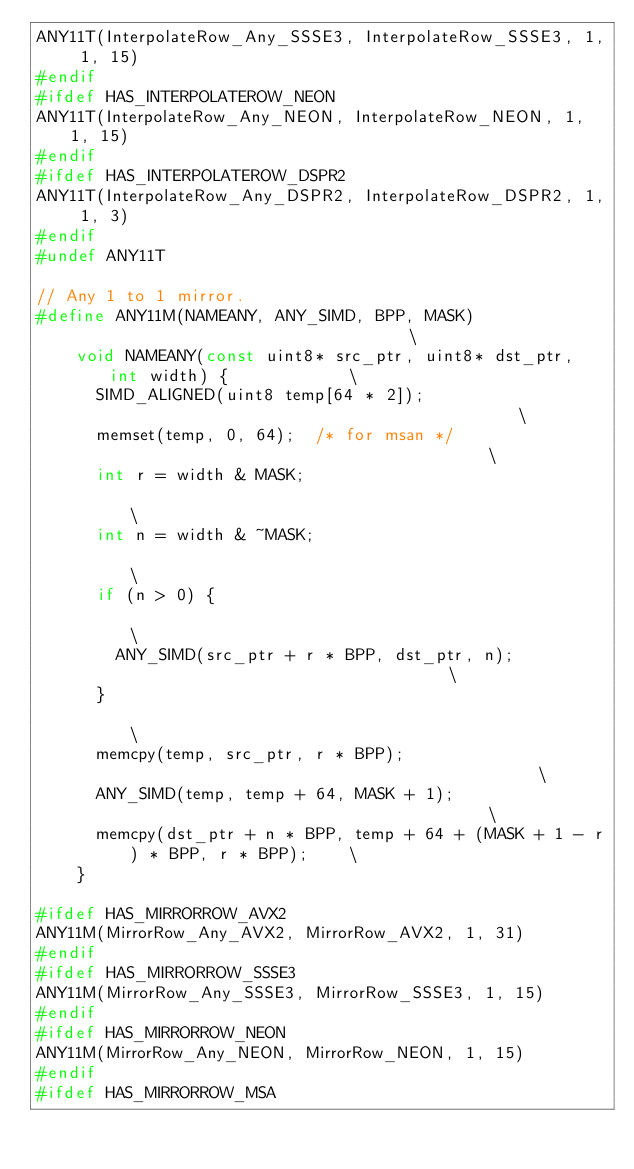Convert code to text. <code><loc_0><loc_0><loc_500><loc_500><_C++_>ANY11T(InterpolateRow_Any_SSSE3, InterpolateRow_SSSE3, 1, 1, 15)
#endif
#ifdef HAS_INTERPOLATEROW_NEON
ANY11T(InterpolateRow_Any_NEON, InterpolateRow_NEON, 1, 1, 15)
#endif
#ifdef HAS_INTERPOLATEROW_DSPR2
ANY11T(InterpolateRow_Any_DSPR2, InterpolateRow_DSPR2, 1, 1, 3)
#endif
#undef ANY11T

// Any 1 to 1 mirror.
#define ANY11M(NAMEANY, ANY_SIMD, BPP, MASK)                                   \
    void NAMEANY(const uint8* src_ptr, uint8* dst_ptr, int width) {            \
      SIMD_ALIGNED(uint8 temp[64 * 2]);                                        \
      memset(temp, 0, 64);  /* for msan */                                     \
      int r = width & MASK;                                                    \
      int n = width & ~MASK;                                                   \
      if (n > 0) {                                                             \
        ANY_SIMD(src_ptr + r * BPP, dst_ptr, n);                               \
      }                                                                        \
      memcpy(temp, src_ptr, r * BPP);                                          \
      ANY_SIMD(temp, temp + 64, MASK + 1);                                     \
      memcpy(dst_ptr + n * BPP, temp + 64 + (MASK + 1 - r) * BPP, r * BPP);    \
    }

#ifdef HAS_MIRRORROW_AVX2
ANY11M(MirrorRow_Any_AVX2, MirrorRow_AVX2, 1, 31)
#endif
#ifdef HAS_MIRRORROW_SSSE3
ANY11M(MirrorRow_Any_SSSE3, MirrorRow_SSSE3, 1, 15)
#endif
#ifdef HAS_MIRRORROW_NEON
ANY11M(MirrorRow_Any_NEON, MirrorRow_NEON, 1, 15)
#endif
#ifdef HAS_MIRRORROW_MSA</code> 